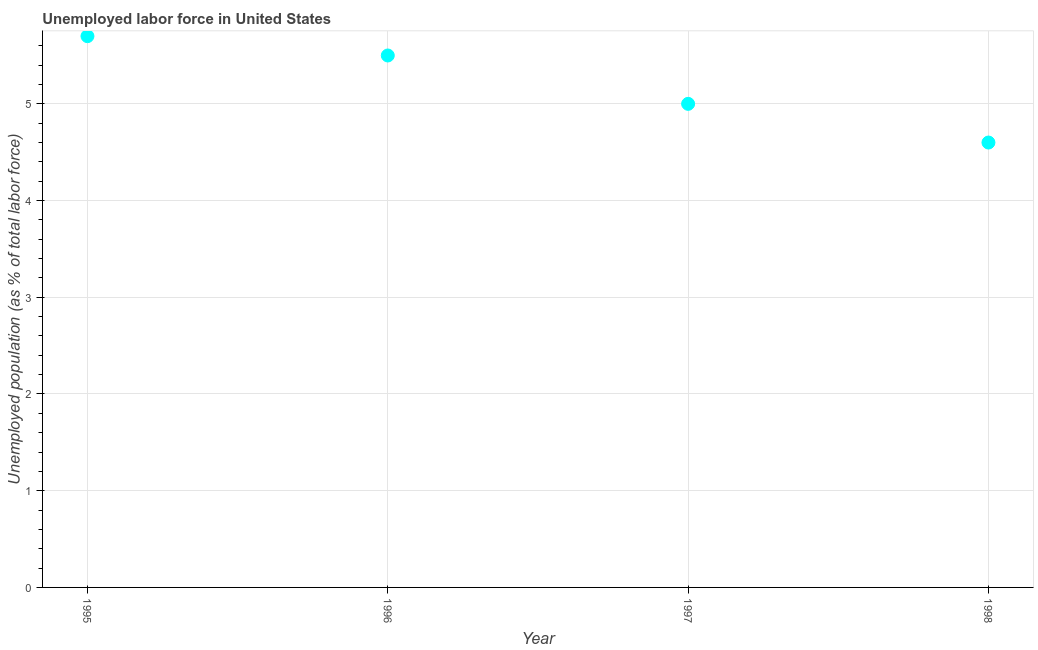What is the total unemployed population in 1998?
Your answer should be compact. 4.6. Across all years, what is the maximum total unemployed population?
Provide a succinct answer. 5.7. Across all years, what is the minimum total unemployed population?
Keep it short and to the point. 4.6. In which year was the total unemployed population maximum?
Your response must be concise. 1995. What is the sum of the total unemployed population?
Make the answer very short. 20.8. What is the difference between the total unemployed population in 1995 and 1998?
Offer a terse response. 1.1. What is the average total unemployed population per year?
Your response must be concise. 5.2. What is the median total unemployed population?
Keep it short and to the point. 5.25. What is the ratio of the total unemployed population in 1997 to that in 1998?
Provide a short and direct response. 1.09. Is the total unemployed population in 1995 less than that in 1997?
Keep it short and to the point. No. What is the difference between the highest and the second highest total unemployed population?
Ensure brevity in your answer.  0.2. What is the difference between the highest and the lowest total unemployed population?
Offer a very short reply. 1.1. Does the total unemployed population monotonically increase over the years?
Provide a short and direct response. No. How many years are there in the graph?
Offer a very short reply. 4. Does the graph contain grids?
Offer a terse response. Yes. What is the title of the graph?
Your answer should be very brief. Unemployed labor force in United States. What is the label or title of the Y-axis?
Give a very brief answer. Unemployed population (as % of total labor force). What is the Unemployed population (as % of total labor force) in 1995?
Offer a terse response. 5.7. What is the Unemployed population (as % of total labor force) in 1998?
Make the answer very short. 4.6. What is the difference between the Unemployed population (as % of total labor force) in 1995 and 1997?
Make the answer very short. 0.7. What is the difference between the Unemployed population (as % of total labor force) in 1996 and 1997?
Provide a succinct answer. 0.5. What is the difference between the Unemployed population (as % of total labor force) in 1996 and 1998?
Offer a terse response. 0.9. What is the difference between the Unemployed population (as % of total labor force) in 1997 and 1998?
Make the answer very short. 0.4. What is the ratio of the Unemployed population (as % of total labor force) in 1995 to that in 1996?
Ensure brevity in your answer.  1.04. What is the ratio of the Unemployed population (as % of total labor force) in 1995 to that in 1997?
Your answer should be very brief. 1.14. What is the ratio of the Unemployed population (as % of total labor force) in 1995 to that in 1998?
Your response must be concise. 1.24. What is the ratio of the Unemployed population (as % of total labor force) in 1996 to that in 1998?
Offer a terse response. 1.2. What is the ratio of the Unemployed population (as % of total labor force) in 1997 to that in 1998?
Your answer should be compact. 1.09. 